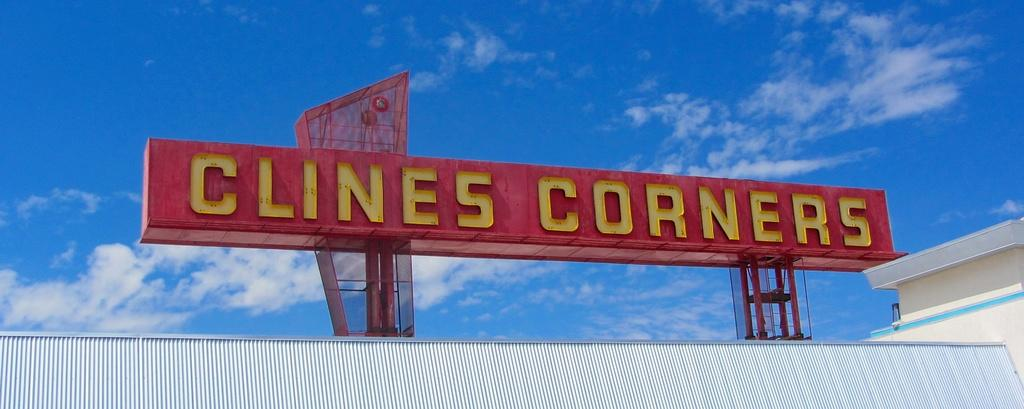Provide a one-sentence caption for the provided image. Clines Corners is being advertised on a Red signboard with yellow letters. 